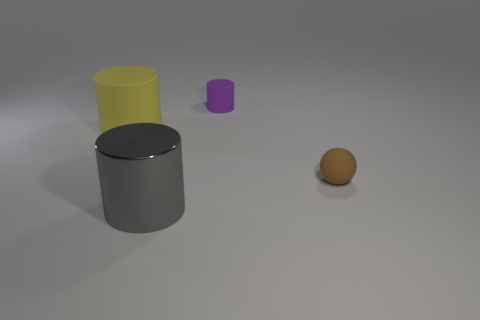Subtract all large gray cylinders. How many cylinders are left? 2 Add 2 things. How many objects exist? 6 Subtract all purple cylinders. How many cylinders are left? 2 Subtract all cylinders. How many objects are left? 1 Subtract 0 red blocks. How many objects are left? 4 Subtract 1 spheres. How many spheres are left? 0 Subtract all yellow spheres. Subtract all cyan cubes. How many spheres are left? 1 Subtract all blue blocks. How many purple cylinders are left? 1 Subtract all red things. Subtract all gray things. How many objects are left? 3 Add 1 big metal objects. How many big metal objects are left? 2 